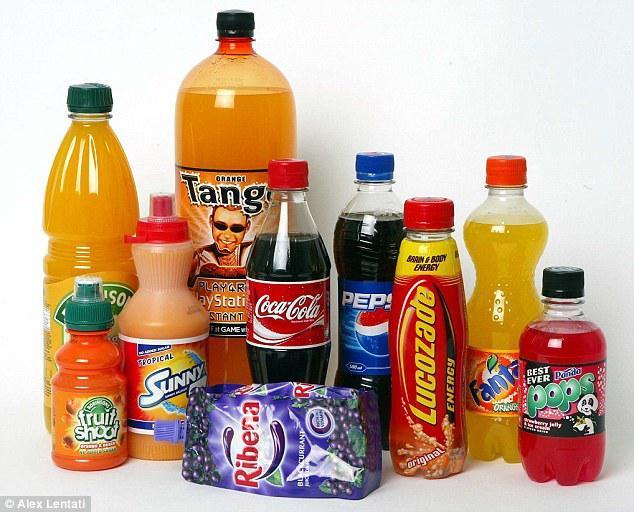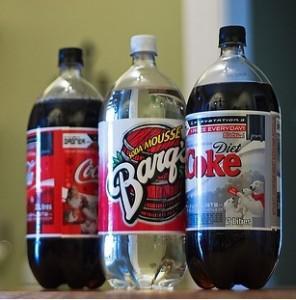The first image is the image on the left, the second image is the image on the right. Examine the images to the left and right. Is the description "There are fewer than seven bottles in total." accurate? Answer yes or no. No. The first image is the image on the left, the second image is the image on the right. Evaluate the accuracy of this statement regarding the images: "No image contains more than four bottles, and the left image shows a row of three bottles that aren't overlapping.". Is it true? Answer yes or no. No. 